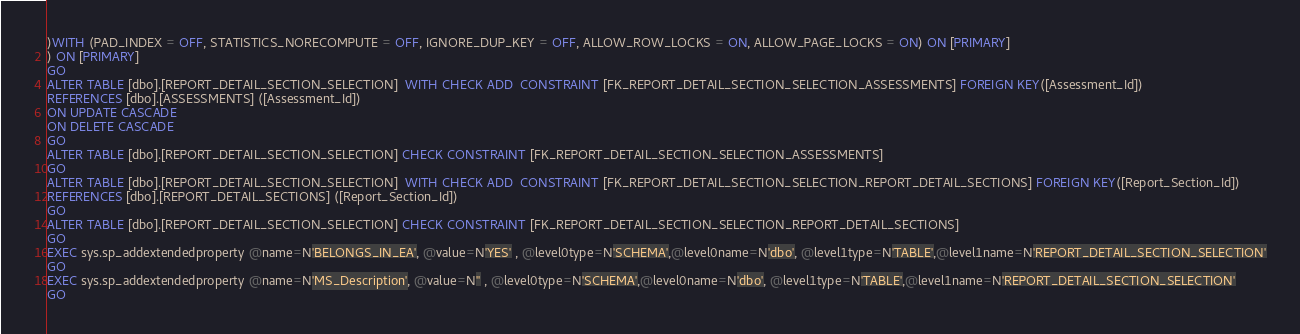Convert code to text. <code><loc_0><loc_0><loc_500><loc_500><_SQL_>)WITH (PAD_INDEX = OFF, STATISTICS_NORECOMPUTE = OFF, IGNORE_DUP_KEY = OFF, ALLOW_ROW_LOCKS = ON, ALLOW_PAGE_LOCKS = ON) ON [PRIMARY]
) ON [PRIMARY]
GO
ALTER TABLE [dbo].[REPORT_DETAIL_SECTION_SELECTION]  WITH CHECK ADD  CONSTRAINT [FK_REPORT_DETAIL_SECTION_SELECTION_ASSESSMENTS] FOREIGN KEY([Assessment_Id])
REFERENCES [dbo].[ASSESSMENTS] ([Assessment_Id])
ON UPDATE CASCADE
ON DELETE CASCADE
GO
ALTER TABLE [dbo].[REPORT_DETAIL_SECTION_SELECTION] CHECK CONSTRAINT [FK_REPORT_DETAIL_SECTION_SELECTION_ASSESSMENTS]
GO
ALTER TABLE [dbo].[REPORT_DETAIL_SECTION_SELECTION]  WITH CHECK ADD  CONSTRAINT [FK_REPORT_DETAIL_SECTION_SELECTION_REPORT_DETAIL_SECTIONS] FOREIGN KEY([Report_Section_Id])
REFERENCES [dbo].[REPORT_DETAIL_SECTIONS] ([Report_Section_Id])
GO
ALTER TABLE [dbo].[REPORT_DETAIL_SECTION_SELECTION] CHECK CONSTRAINT [FK_REPORT_DETAIL_SECTION_SELECTION_REPORT_DETAIL_SECTIONS]
GO
EXEC sys.sp_addextendedproperty @name=N'BELONGS_IN_EA', @value=N'YES' , @level0type=N'SCHEMA',@level0name=N'dbo', @level1type=N'TABLE',@level1name=N'REPORT_DETAIL_SECTION_SELECTION'
GO
EXEC sys.sp_addextendedproperty @name=N'MS_Description', @value=N'' , @level0type=N'SCHEMA',@level0name=N'dbo', @level1type=N'TABLE',@level1name=N'REPORT_DETAIL_SECTION_SELECTION'
GO
</code> 